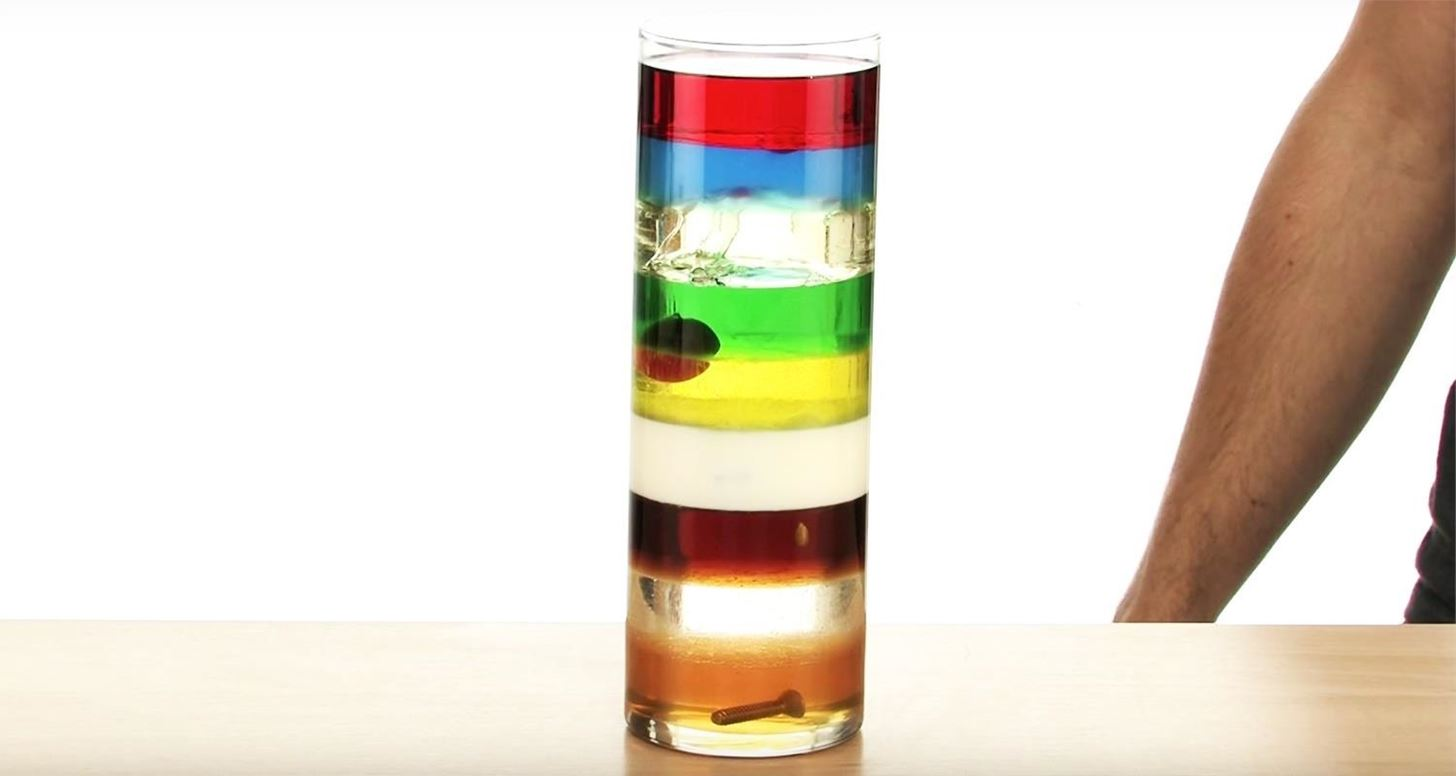What would happen if the layers were disturbed and mixed? If the layers were disturbed and mixed, the liquids would temporarily form a homogenous mixture. However, due to their varying densities, over time, they would gradually separate again into distinct layers. The process of separation might be slower compared to the initial careful layering, resulting in less defined boundaries. Can you explain the science behind why they would still eventually separate? The principle behind the separation is called density stratification. Density stratification occurs because substances with different densities tend to form layers when they are in a gravitational field. The denser the substance, the lower it settles. When the mixture is initially disturbed, all the different density molecules are in random motion, creating a temporary homogenous mixture. Over time, gravity acts on the different molecules causing the denser molecules to move downwards and the less dense ones to move upwards, leading to the reformation of distinct layers. This is a result of each substance seeking the lowest energy state, which in this case, is achieved by forming layers. 